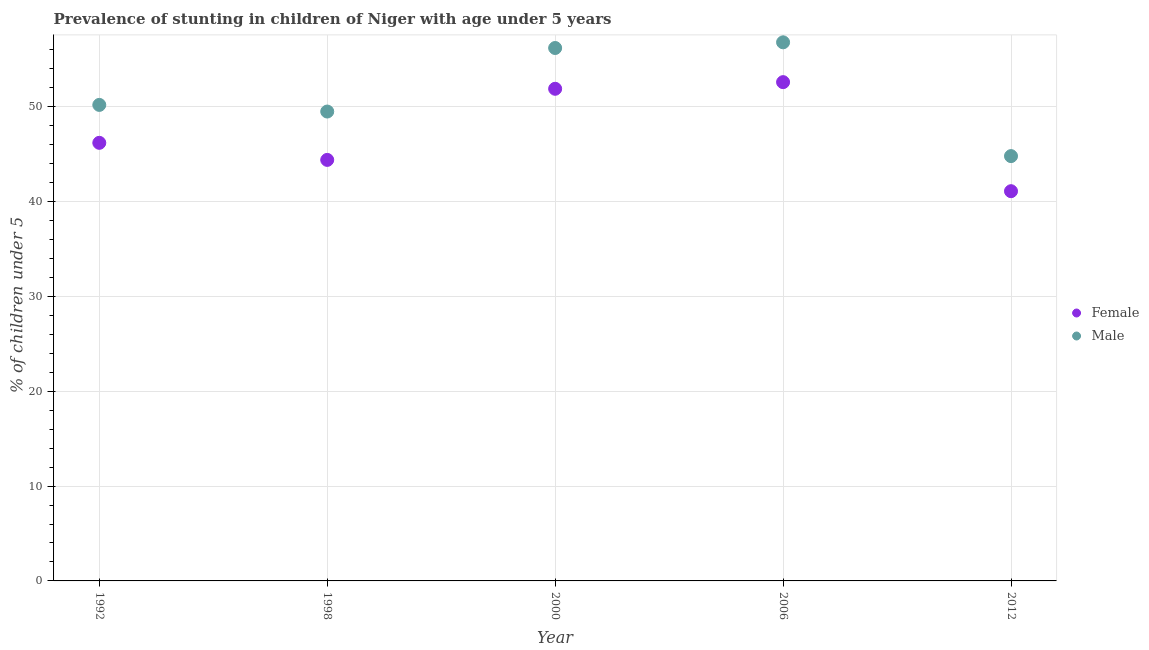How many different coloured dotlines are there?
Ensure brevity in your answer.  2. What is the percentage of stunted female children in 1998?
Your response must be concise. 44.4. Across all years, what is the maximum percentage of stunted male children?
Offer a very short reply. 56.8. Across all years, what is the minimum percentage of stunted female children?
Keep it short and to the point. 41.1. In which year was the percentage of stunted female children maximum?
Your answer should be compact. 2006. In which year was the percentage of stunted female children minimum?
Your answer should be compact. 2012. What is the total percentage of stunted female children in the graph?
Make the answer very short. 236.2. What is the difference between the percentage of stunted female children in 2012 and the percentage of stunted male children in 2000?
Your answer should be compact. -15.1. What is the average percentage of stunted female children per year?
Your answer should be compact. 47.24. In how many years, is the percentage of stunted male children greater than 52 %?
Ensure brevity in your answer.  2. What is the ratio of the percentage of stunted male children in 1992 to that in 2006?
Make the answer very short. 0.88. Is the percentage of stunted female children in 2006 less than that in 2012?
Offer a very short reply. No. What is the difference between the highest and the second highest percentage of stunted female children?
Offer a very short reply. 0.7. In how many years, is the percentage of stunted male children greater than the average percentage of stunted male children taken over all years?
Your answer should be very brief. 2. Is the sum of the percentage of stunted male children in 1998 and 2000 greater than the maximum percentage of stunted female children across all years?
Provide a short and direct response. Yes. Is the percentage of stunted male children strictly greater than the percentage of stunted female children over the years?
Offer a terse response. Yes. Does the graph contain grids?
Offer a very short reply. Yes. Where does the legend appear in the graph?
Provide a succinct answer. Center right. How are the legend labels stacked?
Keep it short and to the point. Vertical. What is the title of the graph?
Ensure brevity in your answer.  Prevalence of stunting in children of Niger with age under 5 years. Does "Methane emissions" appear as one of the legend labels in the graph?
Ensure brevity in your answer.  No. What is the label or title of the Y-axis?
Make the answer very short.  % of children under 5. What is the  % of children under 5 in Female in 1992?
Provide a short and direct response. 46.2. What is the  % of children under 5 of Male in 1992?
Provide a succinct answer. 50.2. What is the  % of children under 5 of Female in 1998?
Make the answer very short. 44.4. What is the  % of children under 5 of Male in 1998?
Provide a succinct answer. 49.5. What is the  % of children under 5 in Female in 2000?
Offer a terse response. 51.9. What is the  % of children under 5 of Male in 2000?
Offer a very short reply. 56.2. What is the  % of children under 5 in Female in 2006?
Provide a succinct answer. 52.6. What is the  % of children under 5 of Male in 2006?
Give a very brief answer. 56.8. What is the  % of children under 5 of Female in 2012?
Give a very brief answer. 41.1. What is the  % of children under 5 of Male in 2012?
Your answer should be very brief. 44.8. Across all years, what is the maximum  % of children under 5 of Female?
Keep it short and to the point. 52.6. Across all years, what is the maximum  % of children under 5 in Male?
Keep it short and to the point. 56.8. Across all years, what is the minimum  % of children under 5 in Female?
Provide a short and direct response. 41.1. Across all years, what is the minimum  % of children under 5 of Male?
Keep it short and to the point. 44.8. What is the total  % of children under 5 in Female in the graph?
Your answer should be compact. 236.2. What is the total  % of children under 5 in Male in the graph?
Provide a short and direct response. 257.5. What is the difference between the  % of children under 5 in Female in 1992 and that in 1998?
Your answer should be very brief. 1.8. What is the difference between the  % of children under 5 of Male in 1992 and that in 1998?
Provide a short and direct response. 0.7. What is the difference between the  % of children under 5 in Male in 1992 and that in 2000?
Provide a succinct answer. -6. What is the difference between the  % of children under 5 in Male in 1992 and that in 2006?
Your answer should be very brief. -6.6. What is the difference between the  % of children under 5 in Male in 1992 and that in 2012?
Make the answer very short. 5.4. What is the difference between the  % of children under 5 of Female in 1998 and that in 2000?
Keep it short and to the point. -7.5. What is the difference between the  % of children under 5 of Male in 1998 and that in 2000?
Provide a succinct answer. -6.7. What is the difference between the  % of children under 5 of Female in 2000 and that in 2006?
Your answer should be compact. -0.7. What is the difference between the  % of children under 5 in Male in 2000 and that in 2006?
Provide a succinct answer. -0.6. What is the difference between the  % of children under 5 of Female in 2000 and that in 2012?
Provide a short and direct response. 10.8. What is the difference between the  % of children under 5 of Male in 2000 and that in 2012?
Offer a terse response. 11.4. What is the difference between the  % of children under 5 of Female in 1992 and the  % of children under 5 of Male in 1998?
Ensure brevity in your answer.  -3.3. What is the difference between the  % of children under 5 of Female in 1998 and the  % of children under 5 of Male in 2000?
Offer a very short reply. -11.8. What is the difference between the  % of children under 5 in Female in 1998 and the  % of children under 5 in Male in 2012?
Provide a succinct answer. -0.4. What is the difference between the  % of children under 5 in Female in 2000 and the  % of children under 5 in Male in 2006?
Your answer should be very brief. -4.9. What is the difference between the  % of children under 5 in Female in 2000 and the  % of children under 5 in Male in 2012?
Provide a short and direct response. 7.1. What is the average  % of children under 5 in Female per year?
Your answer should be compact. 47.24. What is the average  % of children under 5 of Male per year?
Give a very brief answer. 51.5. In the year 1998, what is the difference between the  % of children under 5 in Female and  % of children under 5 in Male?
Make the answer very short. -5.1. In the year 2006, what is the difference between the  % of children under 5 in Female and  % of children under 5 in Male?
Provide a short and direct response. -4.2. In the year 2012, what is the difference between the  % of children under 5 of Female and  % of children under 5 of Male?
Give a very brief answer. -3.7. What is the ratio of the  % of children under 5 of Female in 1992 to that in 1998?
Your response must be concise. 1.04. What is the ratio of the  % of children under 5 of Male in 1992 to that in 1998?
Ensure brevity in your answer.  1.01. What is the ratio of the  % of children under 5 in Female in 1992 to that in 2000?
Make the answer very short. 0.89. What is the ratio of the  % of children under 5 of Male in 1992 to that in 2000?
Make the answer very short. 0.89. What is the ratio of the  % of children under 5 in Female in 1992 to that in 2006?
Make the answer very short. 0.88. What is the ratio of the  % of children under 5 of Male in 1992 to that in 2006?
Offer a terse response. 0.88. What is the ratio of the  % of children under 5 of Female in 1992 to that in 2012?
Give a very brief answer. 1.12. What is the ratio of the  % of children under 5 of Male in 1992 to that in 2012?
Offer a very short reply. 1.12. What is the ratio of the  % of children under 5 of Female in 1998 to that in 2000?
Your response must be concise. 0.86. What is the ratio of the  % of children under 5 in Male in 1998 to that in 2000?
Provide a succinct answer. 0.88. What is the ratio of the  % of children under 5 of Female in 1998 to that in 2006?
Keep it short and to the point. 0.84. What is the ratio of the  % of children under 5 of Male in 1998 to that in 2006?
Make the answer very short. 0.87. What is the ratio of the  % of children under 5 of Female in 1998 to that in 2012?
Offer a very short reply. 1.08. What is the ratio of the  % of children under 5 in Male in 1998 to that in 2012?
Your answer should be compact. 1.1. What is the ratio of the  % of children under 5 of Female in 2000 to that in 2006?
Your answer should be very brief. 0.99. What is the ratio of the  % of children under 5 in Male in 2000 to that in 2006?
Provide a short and direct response. 0.99. What is the ratio of the  % of children under 5 of Female in 2000 to that in 2012?
Provide a short and direct response. 1.26. What is the ratio of the  % of children under 5 in Male in 2000 to that in 2012?
Offer a terse response. 1.25. What is the ratio of the  % of children under 5 in Female in 2006 to that in 2012?
Your response must be concise. 1.28. What is the ratio of the  % of children under 5 of Male in 2006 to that in 2012?
Your response must be concise. 1.27. What is the difference between the highest and the second highest  % of children under 5 in Female?
Your response must be concise. 0.7. What is the difference between the highest and the lowest  % of children under 5 in Female?
Ensure brevity in your answer.  11.5. What is the difference between the highest and the lowest  % of children under 5 of Male?
Your answer should be very brief. 12. 